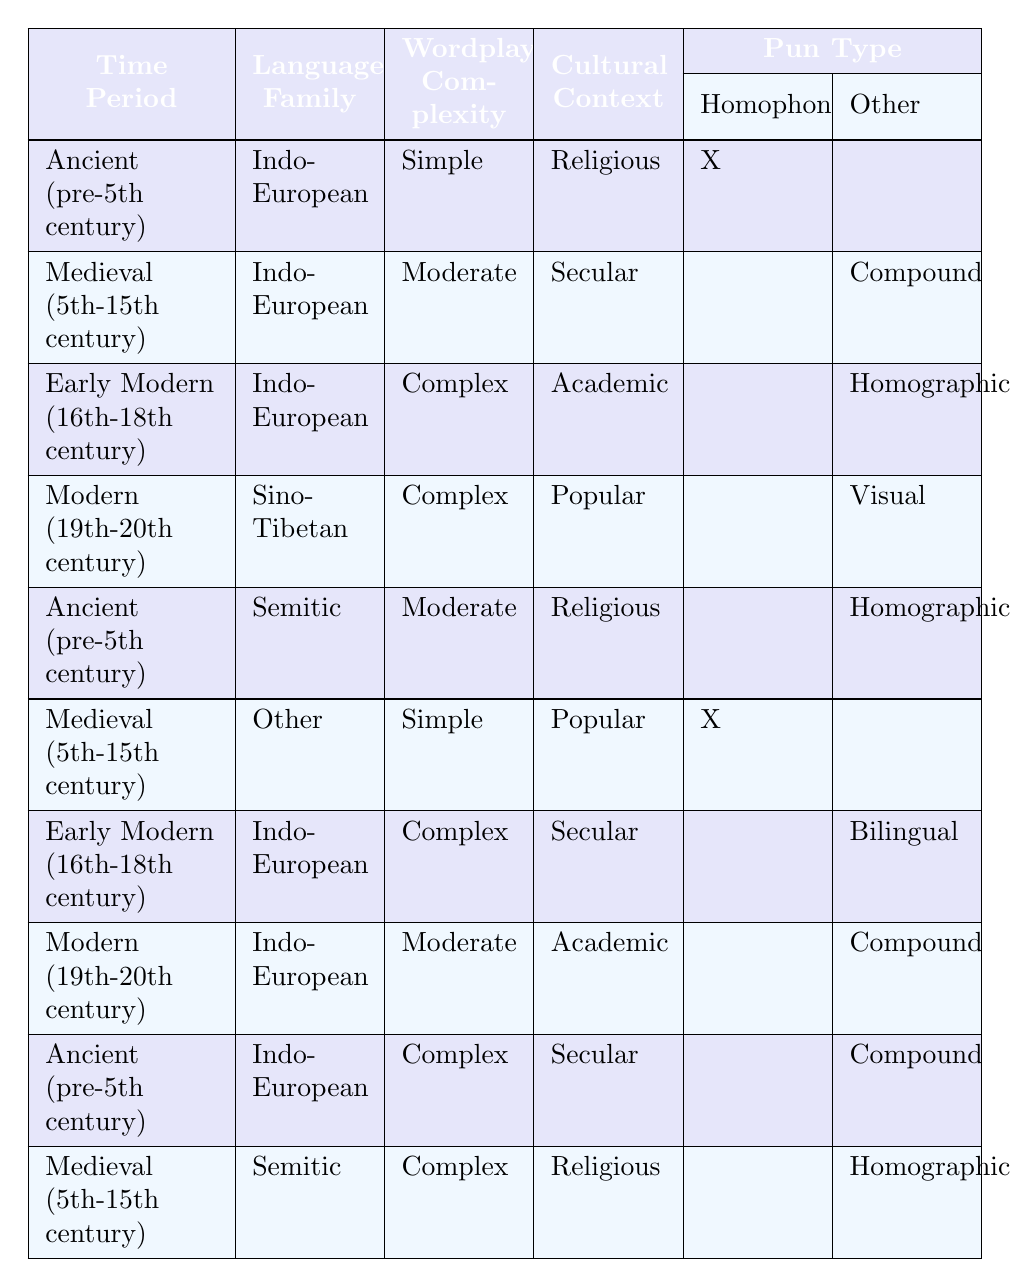What type of pun is classified under Ancient (pre-5th century), Indo-European, Simple, Religious? According to the table, the conditions matching this description are found in the first rule. It states that these conditions yield a "Homophonic" pun type.
Answer: Homophonic How many different pun types are there for the Medieval (5th-15th century) time period? In the table, there are two rows for the Medieval period: one for Indo-European with a "Compound" pun type and one for Semitic with a "Homographic" pun type. Thus, there are two different pun types in total.
Answer: 2 Is there a "Visual" pun type in the Early Modern (16th-18th century)? The table provides details for the Early Modern period, which indicates that the "Visual" pun type is not listed under its conditions. The only pun types listed are "Homographic" and "Bilingual." Therefore, the answer is no.
Answer: No What is the relationship between Wordplay Complexity and Pun Types in the Modern (19th-20th century) period? In the Modern time period, two rows exist: one has "Complex" wordplay with a "Visual" pun type, and another has "Moderate" complexity with a "Compound" pun type. This indicates that both moderate and complex wordplay can lead to different pun types ("Compound" and "Visual").
Answer: Moderate and Complex yield different pun types How often do Homographic pun types appear relative to their conditions? The table shows that the "Homographic" pun type appears three times in total: under Ancient (Semitic), Early Modern (Indo-European), and Medieval (Semitic) periods. Thus, the frequency of "Homographic" puns distributed among its listed conditions is 3 occurrences out of 10 in total conditions.
Answer: 3 occurrences If a pun is categorized as "Bilingual," what could be its possible conditions? By examining the table, the "Bilingual" pun appears only under Early Modern (16th-18th century) with the conditions of Indo-European language family and Complex wordplay complexity while having a Secular cultural context. Thus, these are its exact conditions.
Answer: Early Modern, Indo-European, Complex, Secular 